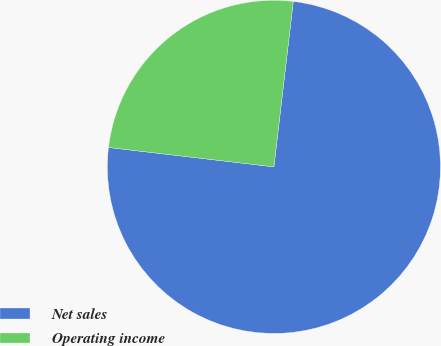<chart> <loc_0><loc_0><loc_500><loc_500><pie_chart><fcel>Net sales<fcel>Operating income<nl><fcel>75.0%<fcel>25.0%<nl></chart> 